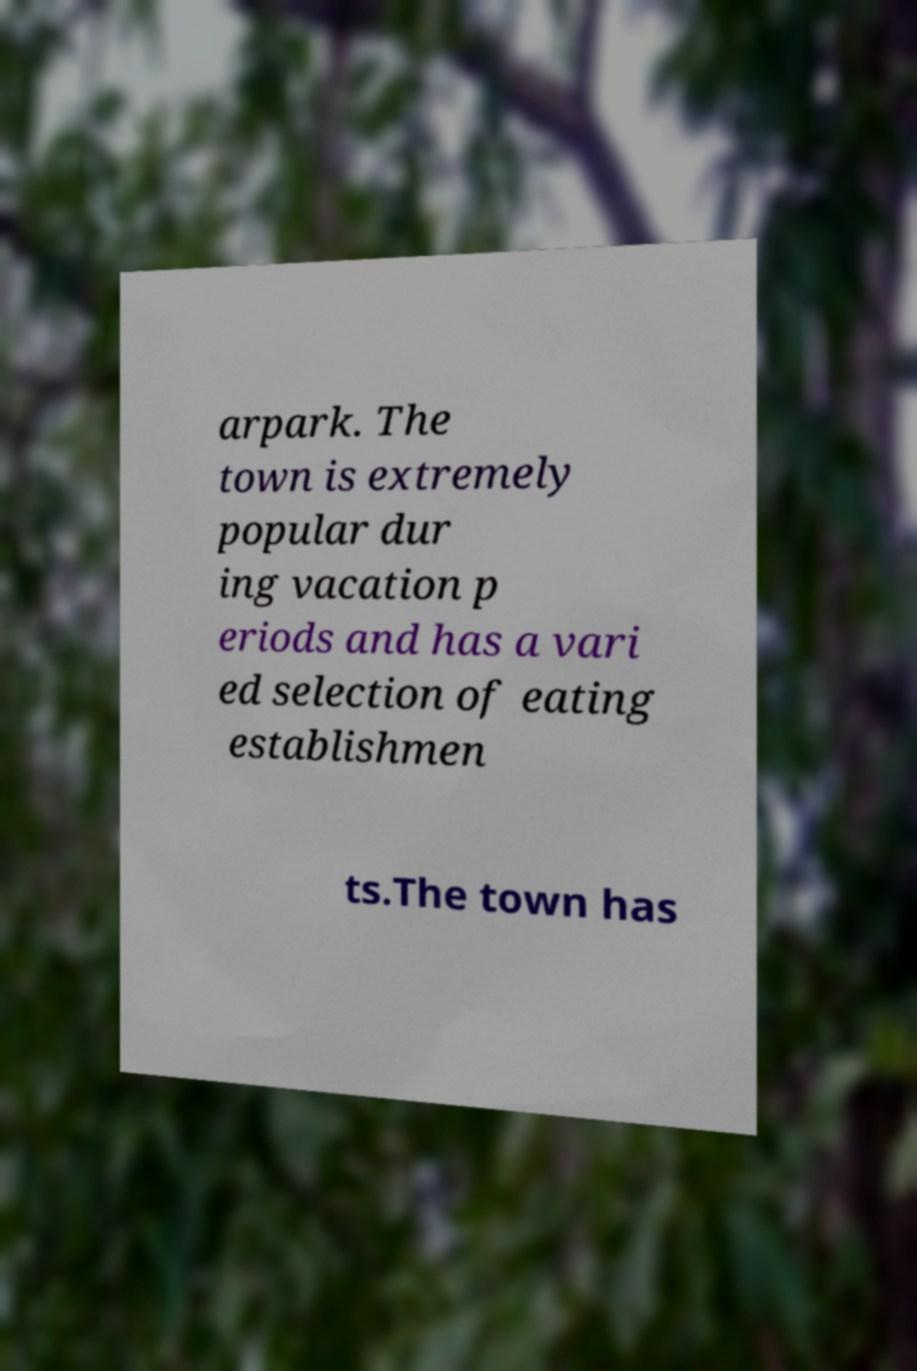Could you extract and type out the text from this image? arpark. The town is extremely popular dur ing vacation p eriods and has a vari ed selection of eating establishmen ts.The town has 